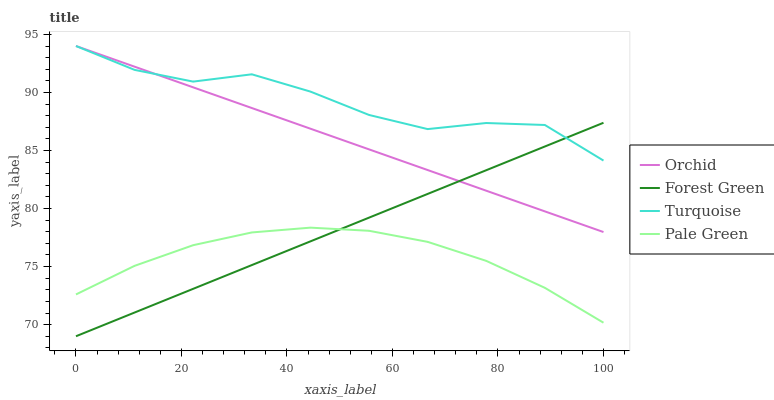Does Pale Green have the minimum area under the curve?
Answer yes or no. Yes. Does Turquoise have the maximum area under the curve?
Answer yes or no. Yes. Does Turquoise have the minimum area under the curve?
Answer yes or no. No. Does Pale Green have the maximum area under the curve?
Answer yes or no. No. Is Forest Green the smoothest?
Answer yes or no. Yes. Is Turquoise the roughest?
Answer yes or no. Yes. Is Pale Green the smoothest?
Answer yes or no. No. Is Pale Green the roughest?
Answer yes or no. No. Does Forest Green have the lowest value?
Answer yes or no. Yes. Does Pale Green have the lowest value?
Answer yes or no. No. Does Orchid have the highest value?
Answer yes or no. Yes. Does Pale Green have the highest value?
Answer yes or no. No. Is Pale Green less than Turquoise?
Answer yes or no. Yes. Is Turquoise greater than Pale Green?
Answer yes or no. Yes. Does Forest Green intersect Pale Green?
Answer yes or no. Yes. Is Forest Green less than Pale Green?
Answer yes or no. No. Is Forest Green greater than Pale Green?
Answer yes or no. No. Does Pale Green intersect Turquoise?
Answer yes or no. No. 